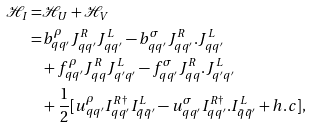Convert formula to latex. <formula><loc_0><loc_0><loc_500><loc_500>\mathcal { H } _ { I } = & \mathcal { H } _ { U } + \mathcal { H } _ { V } \\ = & b ^ { \rho } _ { q q ^ { \prime } } J ^ { R } _ { q q ^ { \prime } } J ^ { L } _ { q q ^ { \prime } } - b ^ { \sigma } _ { q q ^ { \prime } } J ^ { R } _ { q q ^ { \prime } } . J ^ { L } _ { q q ^ { \prime } } \\ & + f ^ { \rho } _ { q q ^ { \prime } } J ^ { R } _ { q q } J ^ { L } _ { q ^ { \prime } q ^ { \prime } } - f ^ { \sigma } _ { q q ^ { \prime } } J ^ { R } _ { q q } . J ^ { L } _ { q ^ { \prime } q ^ { \prime } } \\ & + \frac { 1 } { 2 } [ u ^ { \rho } _ { q q ^ { \prime } } I ^ { R \dag } _ { q q ^ { \prime } } I ^ { L } _ { \bar { q } \bar { q } ^ { \prime } } - u ^ { \sigma } _ { q q ^ { \prime } } I ^ { R \dag } _ { q q ^ { \prime } } . I ^ { L } _ { \bar { q } \bar { q } ^ { \prime } } + h . c ] ,</formula> 